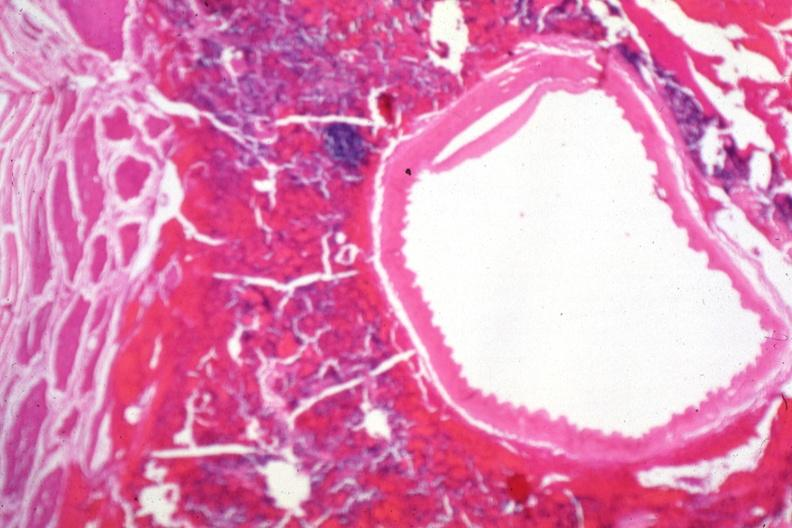does hemorrhage newborn show carotid artery near sella with tumor cells in soft tissue?
Answer the question using a single word or phrase. No 